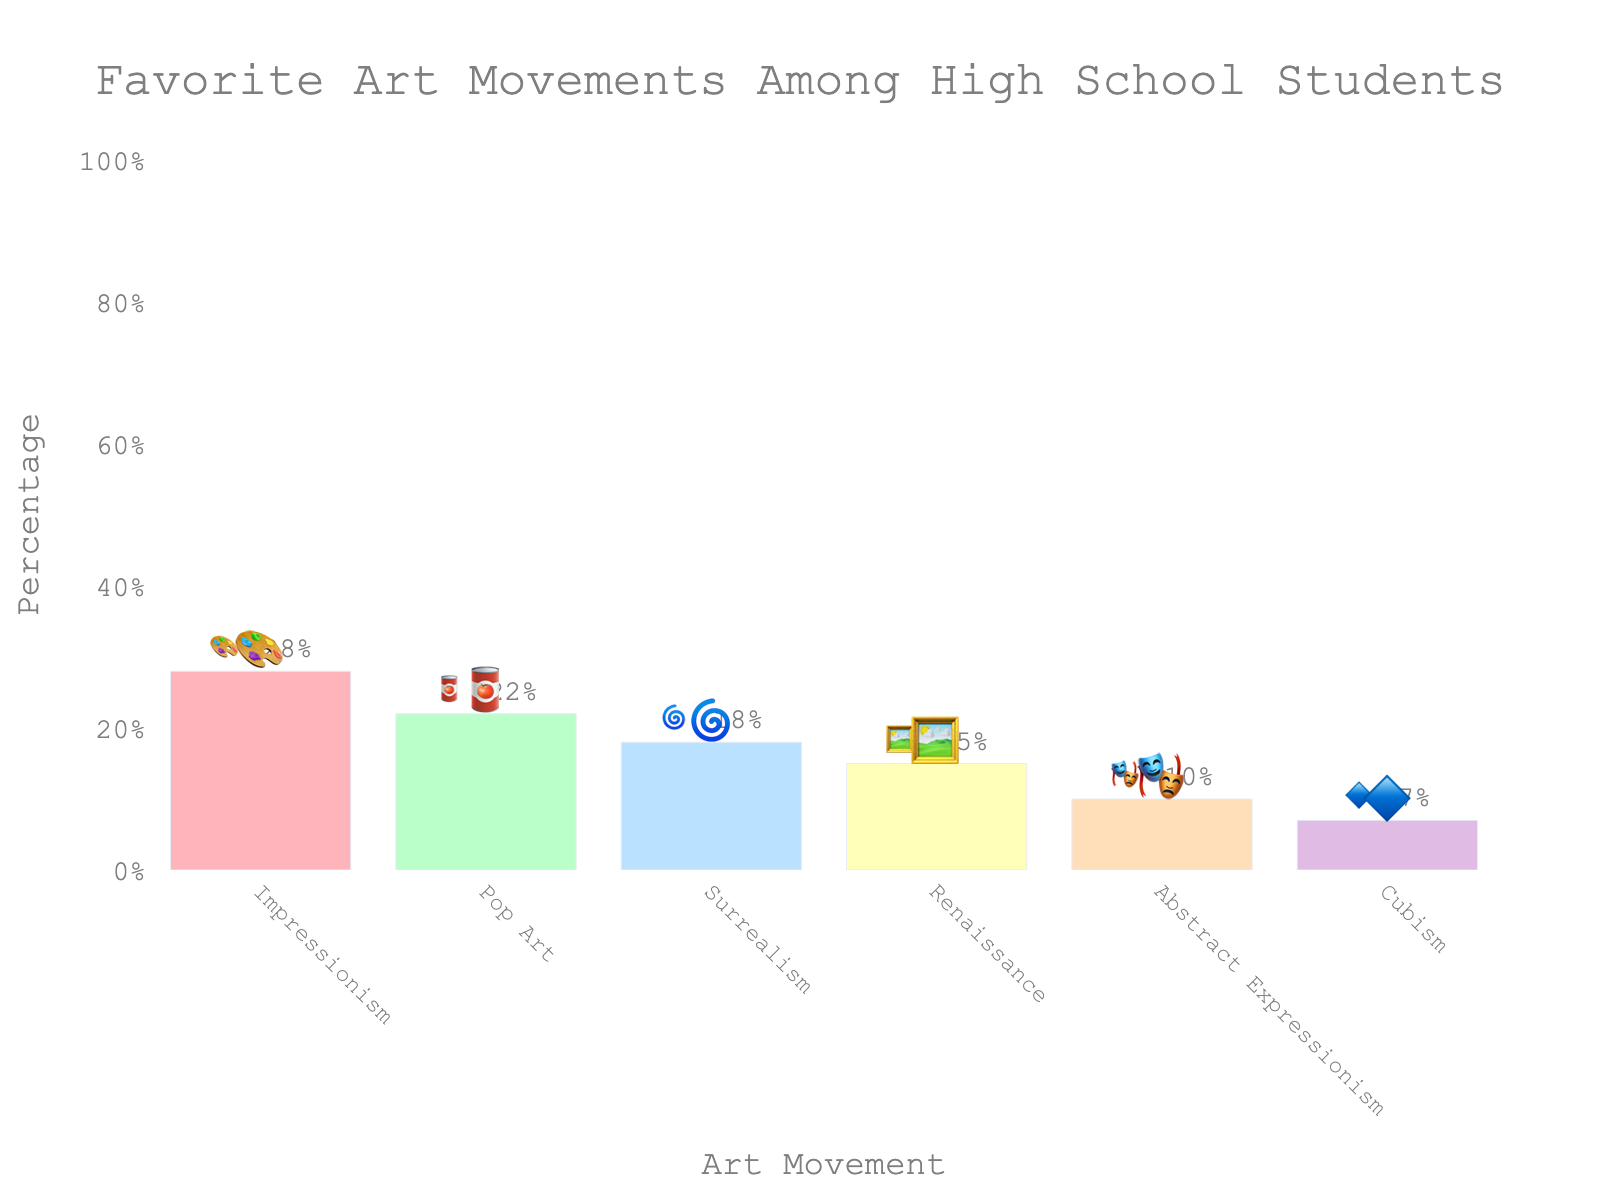What art movement has the highest percentage? The figure shows the percentage distribution of favorite art movements among high school students. The bar with the highest value indicates the movement with the highest percentage.
Answer: Impressionism Which art movement is represented by the 🥫 emoji? Looking at the bar chart, you can see that the 🥫 emoji is next to the Pop Art bar.
Answer: Pop Art What is the combined percentage of students who favor Renaissance and Cubism? To find this, sum the percentages of Renaissance (15%) and Cubism (7%). 15 + 7 = 22%.
Answer: 22% Which has a higher percentage: Surrealism or Abstract Expressionism? By comparing the heights of the bars for Surrealism (18%) and Abstract Expressionism (10%), we see that Surrealism is higher.
Answer: Surrealism What is the sum of the percentages for the top three art movements? Add the percentages of the top three movements: Impressionism (28%), Pop Art (22%), and Surrealism (18%). 28 + 22 + 18 = 68%.
Answer: 68% What's the title of the figure? The title is displayed at the top of the chart. It reads "Favorite Art Movements Among High School Students".
Answer: Favorite Art Movements Among High School Students Which art movement has the smallest percentage of high school student favorites? The bar chart shows the lowest percentage for Cubism, represented by 7%.
Answer: Cubism Among the movements represented by 🎨, 🥫, and 🌀 emojis, which has the middle percentage value? The percentages for 🎨 (Impressionism) is 28%, 🥫 (Pop Art) is 22%, and 🌀 (Surrealism) is 18%. The middle value is 22% for Pop Art.
Answer: Pop Art Are the percentages evenly distributed among the art movements? Observing the heights and percentages of the bars, the distribution is uneven, with some movements much higher in preference than others.
Answer: No 